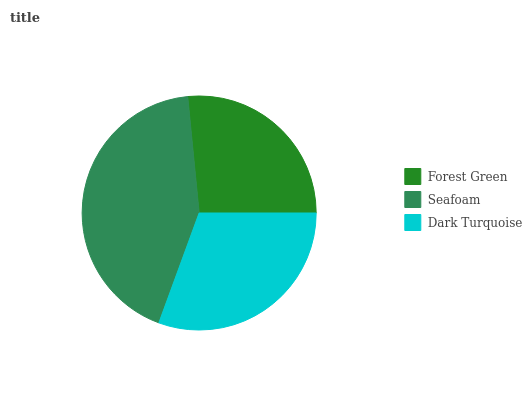Is Forest Green the minimum?
Answer yes or no. Yes. Is Seafoam the maximum?
Answer yes or no. Yes. Is Dark Turquoise the minimum?
Answer yes or no. No. Is Dark Turquoise the maximum?
Answer yes or no. No. Is Seafoam greater than Dark Turquoise?
Answer yes or no. Yes. Is Dark Turquoise less than Seafoam?
Answer yes or no. Yes. Is Dark Turquoise greater than Seafoam?
Answer yes or no. No. Is Seafoam less than Dark Turquoise?
Answer yes or no. No. Is Dark Turquoise the high median?
Answer yes or no. Yes. Is Dark Turquoise the low median?
Answer yes or no. Yes. Is Seafoam the high median?
Answer yes or no. No. Is Forest Green the low median?
Answer yes or no. No. 